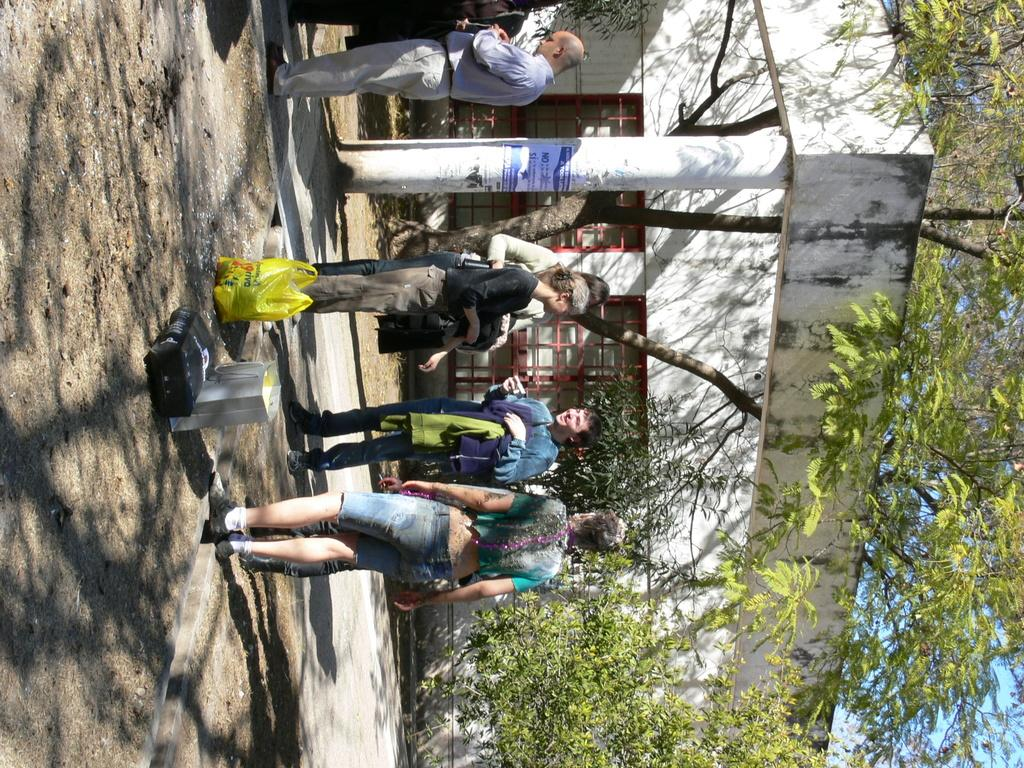What is happening in front of the building in the image? There are people standing in front of a building, and they are talking. What else can be seen in the image besides the people and the building? There are objects placed nearby, and trees are visible around the area. What type of zephyr can be seen blowing through the area in the image? There is no zephyr present in the image; it is a term for a gentle breeze, and there is no indication of wind in the image. 